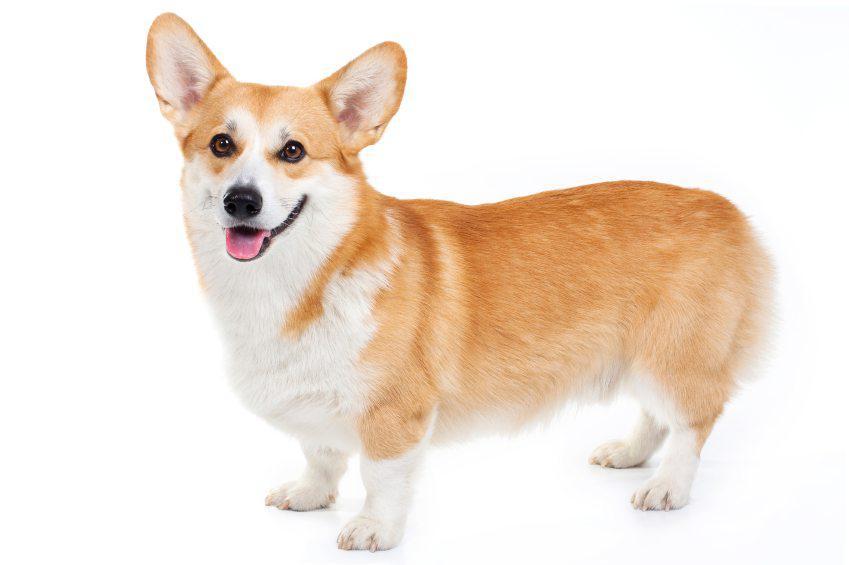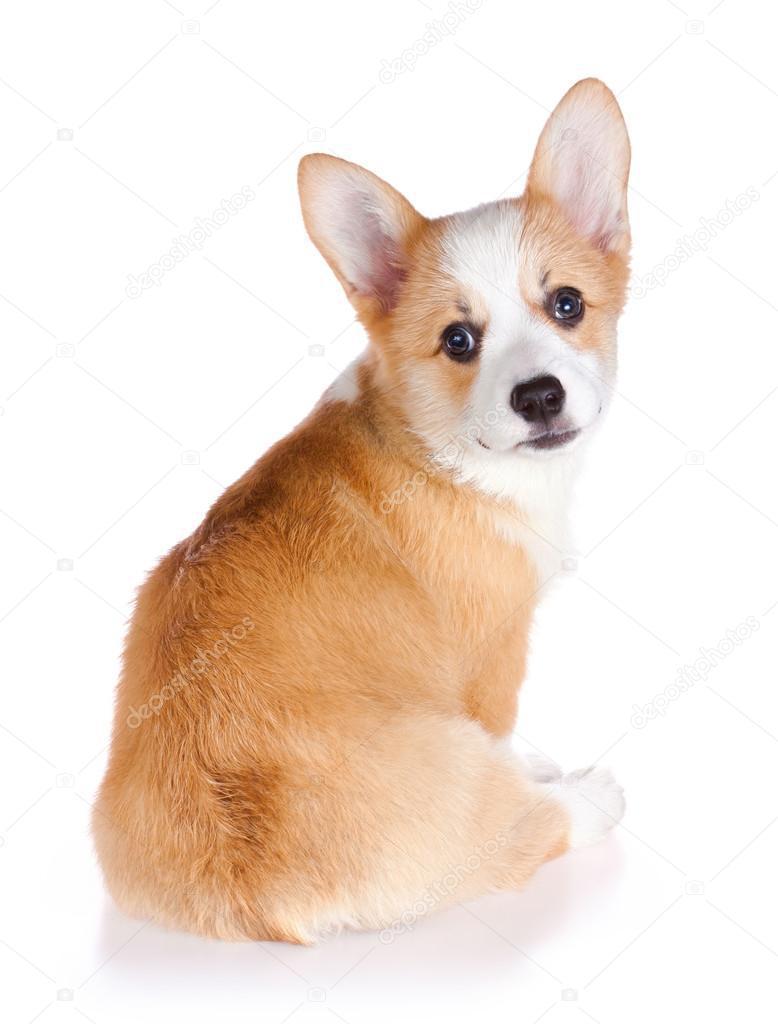The first image is the image on the left, the second image is the image on the right. Given the left and right images, does the statement "One image shows a pair of camera-facing dogs with their heads next to one another." hold true? Answer yes or no. No. The first image is the image on the left, the second image is the image on the right. Considering the images on both sides, is "The right image contains exactly two dogs." valid? Answer yes or no. No. 